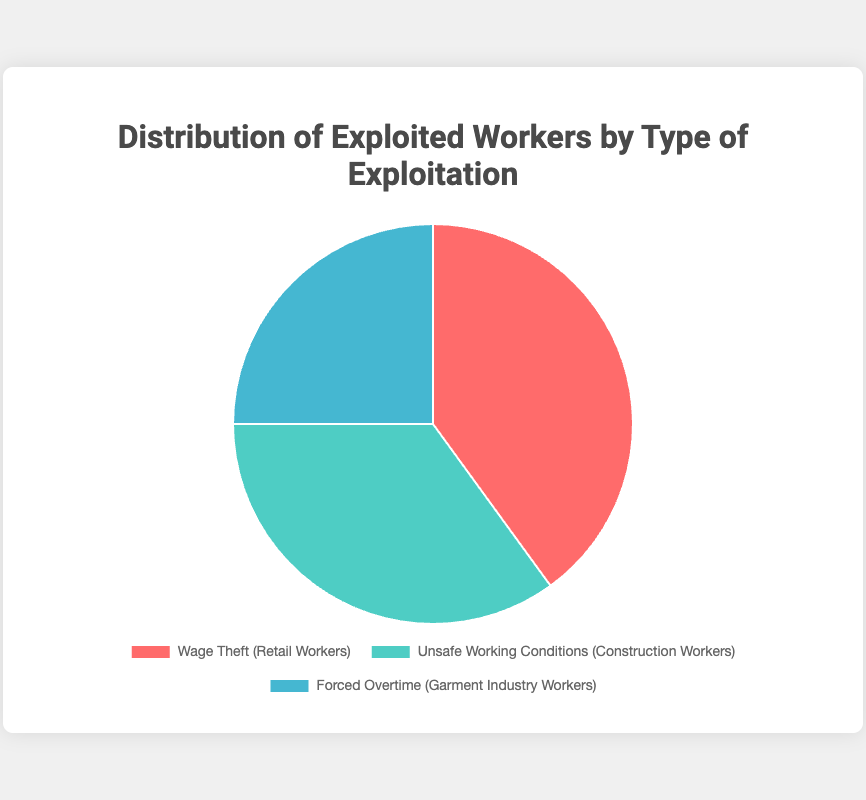What is the percentage of retail workers who experience wage theft? Look at the segment labeled "Wage Theft (Retail Workers)" which has a labeled percentage of 40%.
Answer: 40% Which type of exploitation has the largest percentage of affected workers? Compare the percentages of all types of exploitation visible in the segments: Wage Theft (40%), Unsafe Working Conditions (35%), Forced Overtime (25%). Wage Theft has the largest percentage.
Answer: Wage Theft How much higher is the percentage of Wage Theft compared to Forced Overtime? Subtract the percentage of Forced Overtime (25%) from the percentage of Wage Theft (40%) which gives 40% - 25% = 15%.
Answer: 15% What is the combined percentage of workers affected by Unsafe Working Conditions and Forced Overtime? Add the percentages of Unsafe Working Conditions (35%) and Forced Overtime (25%), which is 35% + 25% = 60%.
Answer: 60% Which type of exploitation affects construction workers, and what percentage does it represent? Look for the segment labeled "Unsafe Working Conditions (Construction Workers)" which shows a percentage of 35%.
Answer: Unsafe Working Conditions, 35% What is the difference in percentage between construction workers facing Unsafe Working Conditions and retail workers facing Wage Theft? Subtract the percentage of Unsafe Working Conditions (35%) from the percentage of Wage Theft (40%), which results in 40% - 35% = 5%.
Answer: 5% Which segment is represented in blue and what percentage does it have? Identify the color coded in blue which corresponds to "Forced Overtime (Garment Industry Workers)" with a percentage of 25%.
Answer: Forced Overtime (Garment Industry Workers), 25% How much more likely are workers to face Wage Theft than Forced Overtime? Divide the percentage of Wage Theft (40%) by the percentage of Forced Overtime (25%), which results in 40% / 25% = 1.6, meaning Wage Theft is 1.6 times more likely.
Answer: 1.6 times How many types of exploitation affect workers and what are their collective percentages? Count the segments and add their percentages: Wage Theft (40%), Unsafe Working Conditions (35%), Forced Overtime (25%) which add to 100%.
Answer: 3 types, 100% What visual attribute is used to differentiate the types of exploitation? Different colors are used for different types: red for Wage Theft, green for Unsafe Working Conditions, and blue for Forced Overtime.
Answer: Colors 